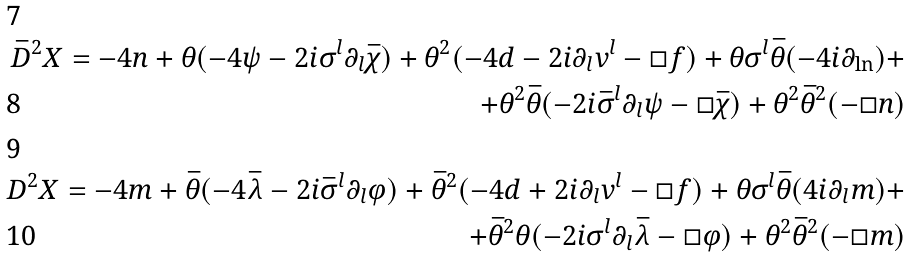Convert formula to latex. <formula><loc_0><loc_0><loc_500><loc_500>\bar { D } ^ { 2 } X = - 4 n + \theta ( - 4 \psi - 2 i \sigma ^ { l } \partial _ { l } \bar { \chi } ) + \theta ^ { 2 } ( - 4 d - 2 i \partial _ { l } v ^ { l } - \square f ) + \theta \sigma ^ { l } \bar { \theta } ( - 4 i \partial _ { \ln } ) + \\ + \theta ^ { 2 } \bar { \theta } ( - 2 i \bar { \sigma } ^ { l } \partial _ { l } \psi - \square \bar { \chi } ) + \theta ^ { 2 } \bar { \theta } ^ { 2 } ( - \square n ) \\ D ^ { 2 } X = - 4 m + \bar { \theta } ( - 4 \bar { \lambda } - 2 i \bar { \sigma } ^ { l } \partial _ { l } \varphi ) + \bar { \theta } ^ { 2 } ( - 4 d + 2 i \partial _ { l } v ^ { l } - \square f ) + \theta \sigma ^ { l } \bar { \theta } ( 4 i \partial _ { l } m ) + \\ + \bar { \theta } ^ { 2 } \theta ( - 2 i \sigma ^ { l } \partial _ { l } \bar { \lambda } - \square \varphi ) + \theta ^ { 2 } \bar { \theta } ^ { 2 } ( - \square m )</formula> 